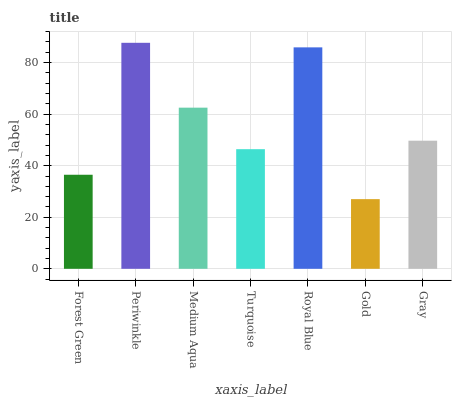Is Gold the minimum?
Answer yes or no. Yes. Is Periwinkle the maximum?
Answer yes or no. Yes. Is Medium Aqua the minimum?
Answer yes or no. No. Is Medium Aqua the maximum?
Answer yes or no. No. Is Periwinkle greater than Medium Aqua?
Answer yes or no. Yes. Is Medium Aqua less than Periwinkle?
Answer yes or no. Yes. Is Medium Aqua greater than Periwinkle?
Answer yes or no. No. Is Periwinkle less than Medium Aqua?
Answer yes or no. No. Is Gray the high median?
Answer yes or no. Yes. Is Gray the low median?
Answer yes or no. Yes. Is Medium Aqua the high median?
Answer yes or no. No. Is Forest Green the low median?
Answer yes or no. No. 